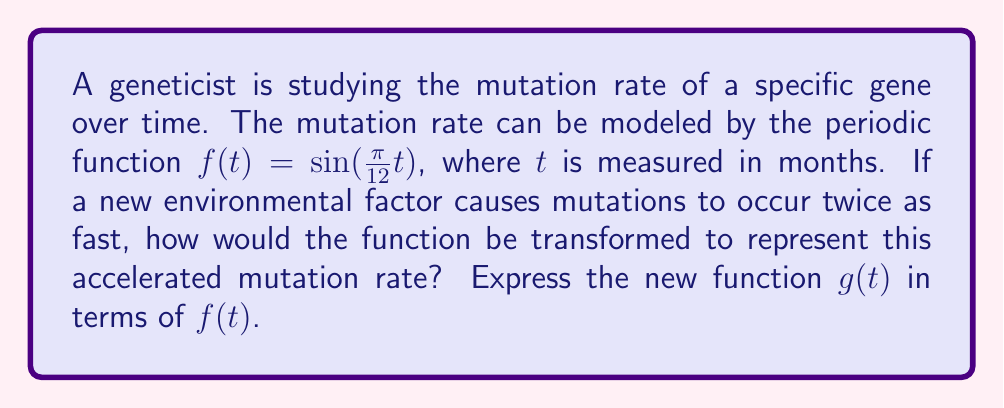Could you help me with this problem? To solve this problem, we need to understand how transformations affect periodic functions:

1. The original function $f(t) = \sin(\frac{\pi}{12}t)$ has a period of 24 months, as $\sin(x)$ has a period of $2\pi$:

   $\frac{\pi}{12}t = 2\pi$
   $t = 24$

2. If mutations occur twice as fast, the new period should be half of the original, i.e., 12 months.

3. To compress the function horizontally (which represents speeding up the process), we multiply the input variable by a factor. Let's call this factor $k$:

   $g(t) = f(kt) = \sin(\frac{\pi}{12}kt)$

4. To find $k$, we set the new period to 12:

   $\frac{\pi}{12}kt = 2\pi$
   $kt = 24$
   $k = 2$ (when $t = 12$)

5. Therefore, the new function is:

   $g(t) = f(2t) = \sin(\frac{\pi}{12}(2t)) = \sin(\frac{\pi}{6}t)$

6. We can express this in terms of the original function $f(t)$:

   $g(t) = f(2t)$

This transformation compresses the function horizontally by a factor of 2, effectively doubling the frequency of the sine wave and representing the accelerated mutation rate.
Answer: $g(t) = f(2t)$ 